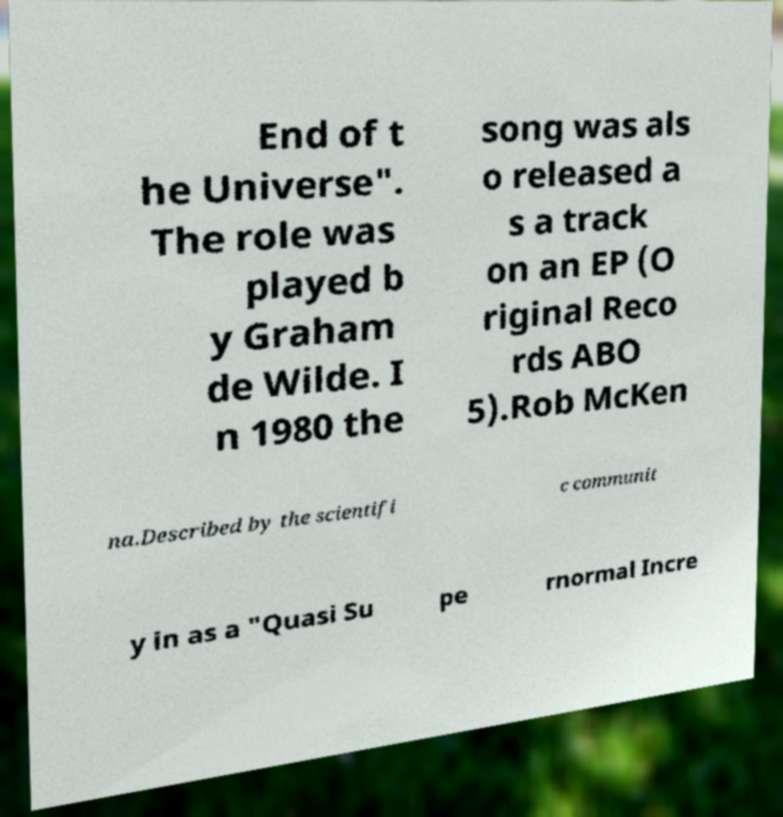Can you accurately transcribe the text from the provided image for me? End of t he Universe". The role was played b y Graham de Wilde. I n 1980 the song was als o released a s a track on an EP (O riginal Reco rds ABO 5).Rob McKen na.Described by the scientifi c communit y in as a "Quasi Su pe rnormal Incre 